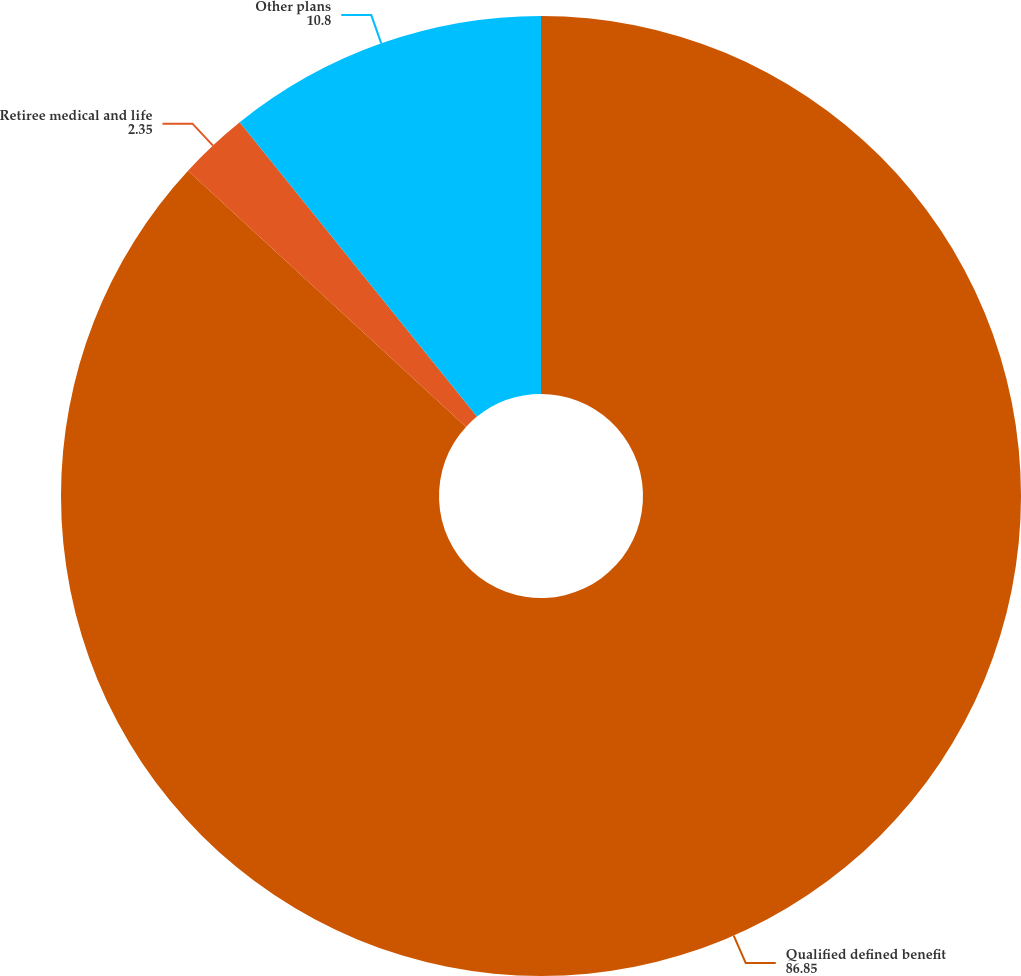Convert chart to OTSL. <chart><loc_0><loc_0><loc_500><loc_500><pie_chart><fcel>Qualified defined benefit<fcel>Retiree medical and life<fcel>Other plans<nl><fcel>86.85%<fcel>2.35%<fcel>10.8%<nl></chart> 